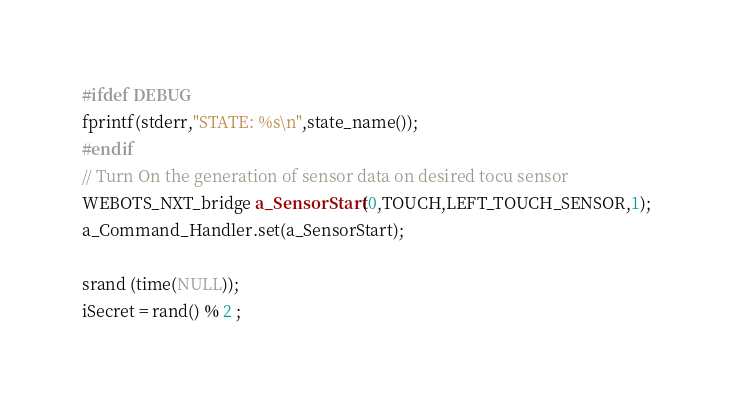Convert code to text. <code><loc_0><loc_0><loc_500><loc_500><_ObjectiveC_>#ifdef DEBUG
fprintf(stderr,"STATE: %s\n",state_name()); 
#endif
// Turn On the generation of sensor data on desired tocu sensor
WEBOTS_NXT_bridge a_SensorStart(0,TOUCH,LEFT_TOUCH_SENSOR,1);
a_Command_Handler.set(a_SensorStart);

srand (time(NULL));
iSecret = rand() % 2 ;
</code> 